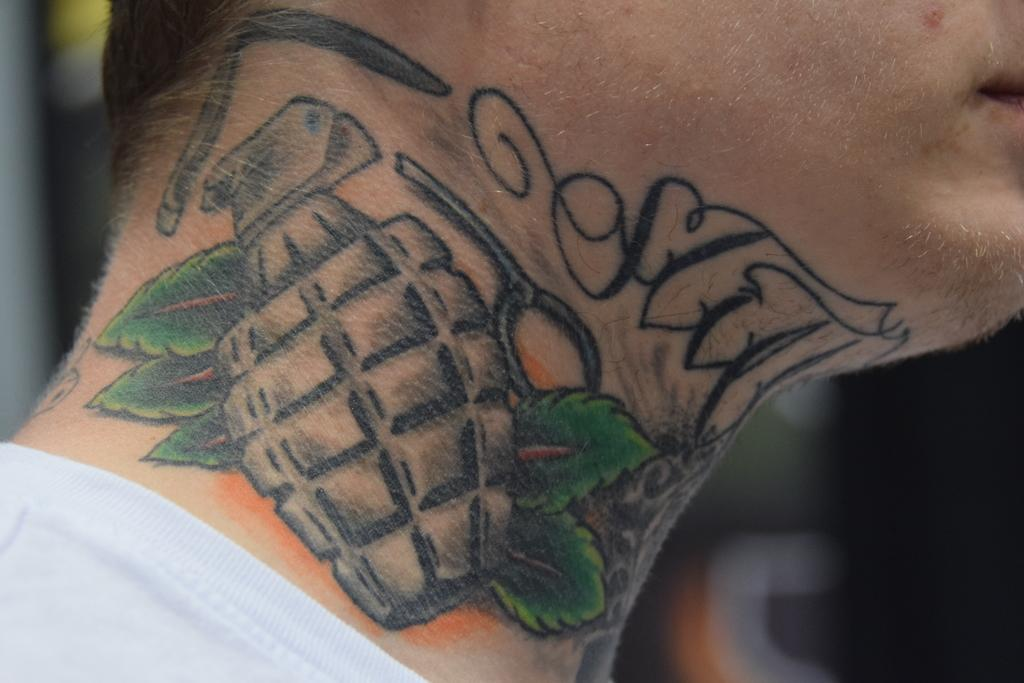What is present on the neck of the person in the image? There is a tattoo present on the neck of a person in the image. What type of cable is being used to decorate the cake in the image? There is no cake or cable present in the image; it only features a tattoo on the neck of a person. 